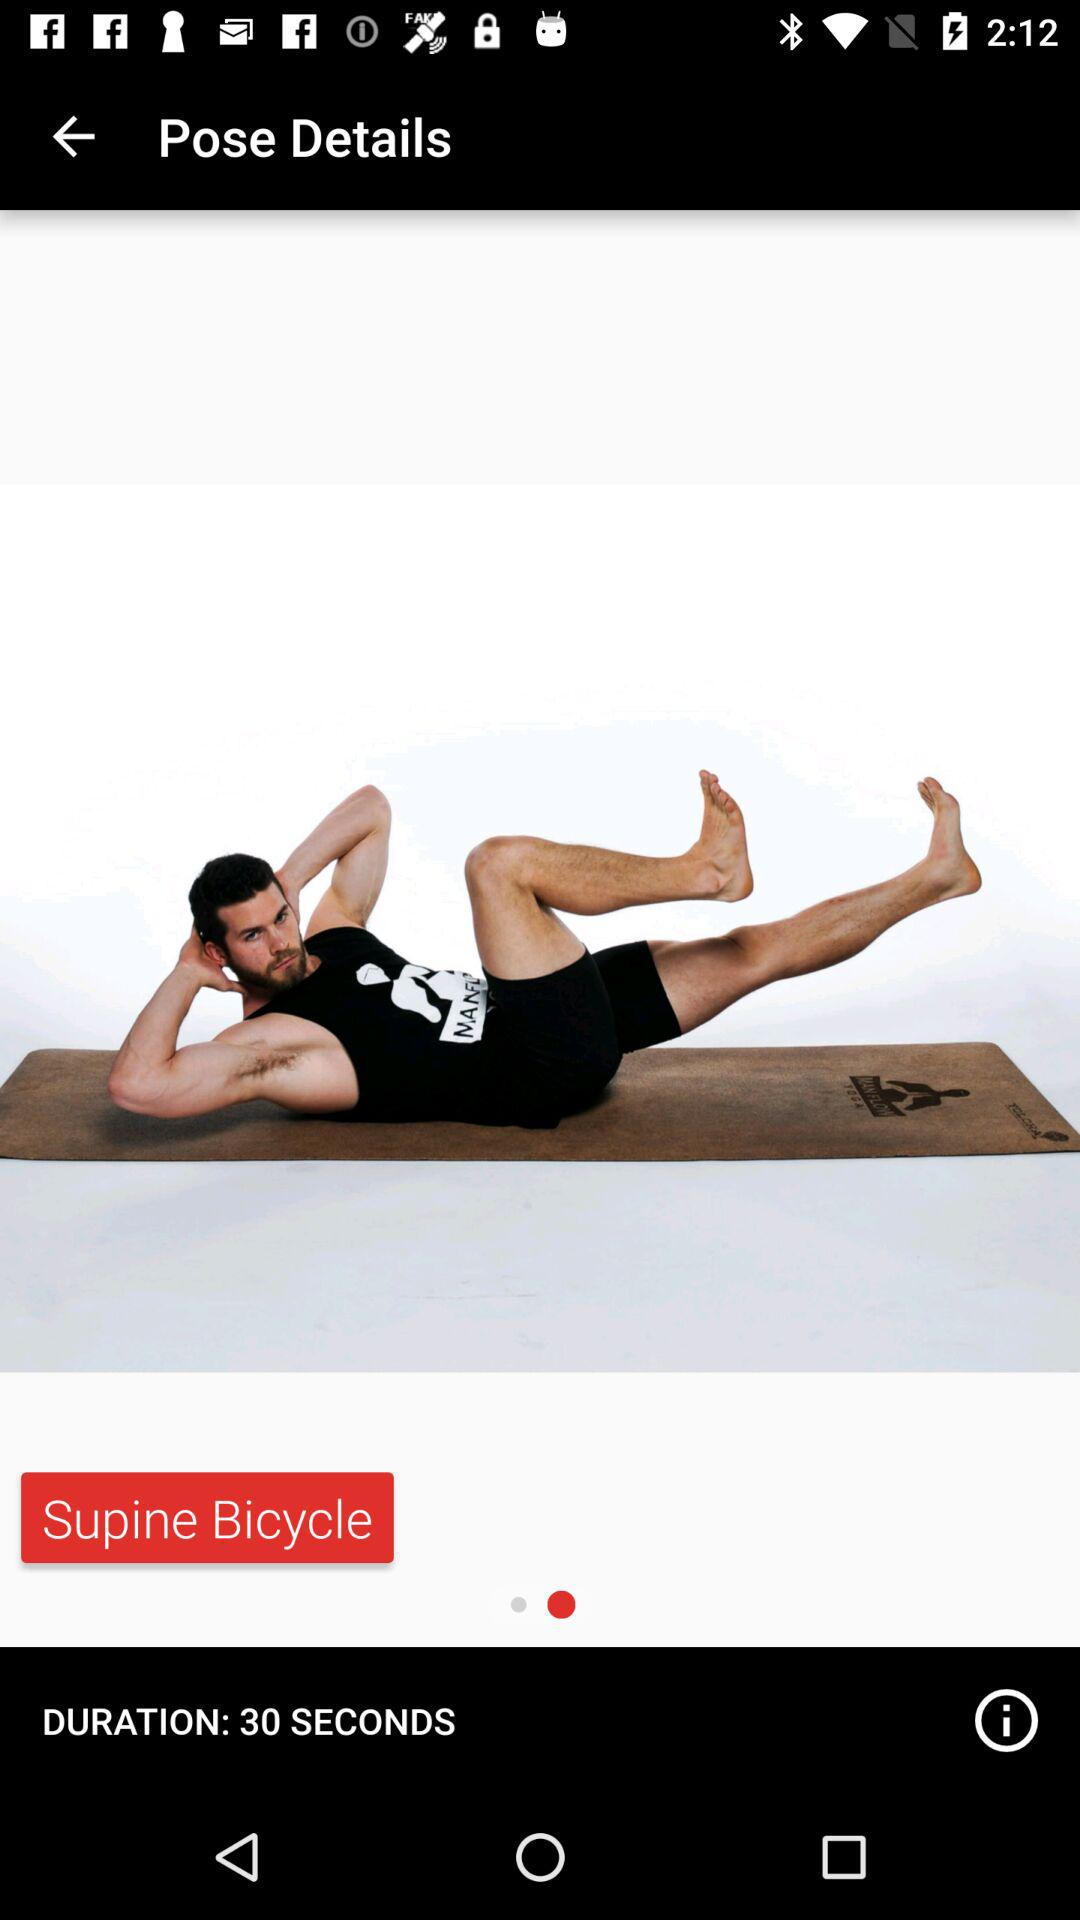How many seconds is the duration of the pose?
Answer the question using a single word or phrase. 30 